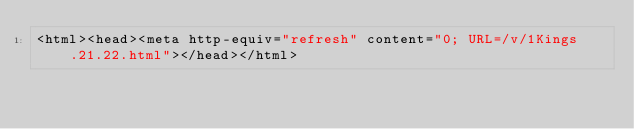Convert code to text. <code><loc_0><loc_0><loc_500><loc_500><_HTML_><html><head><meta http-equiv="refresh" content="0; URL=/v/1Kings.21.22.html"></head></html></code> 